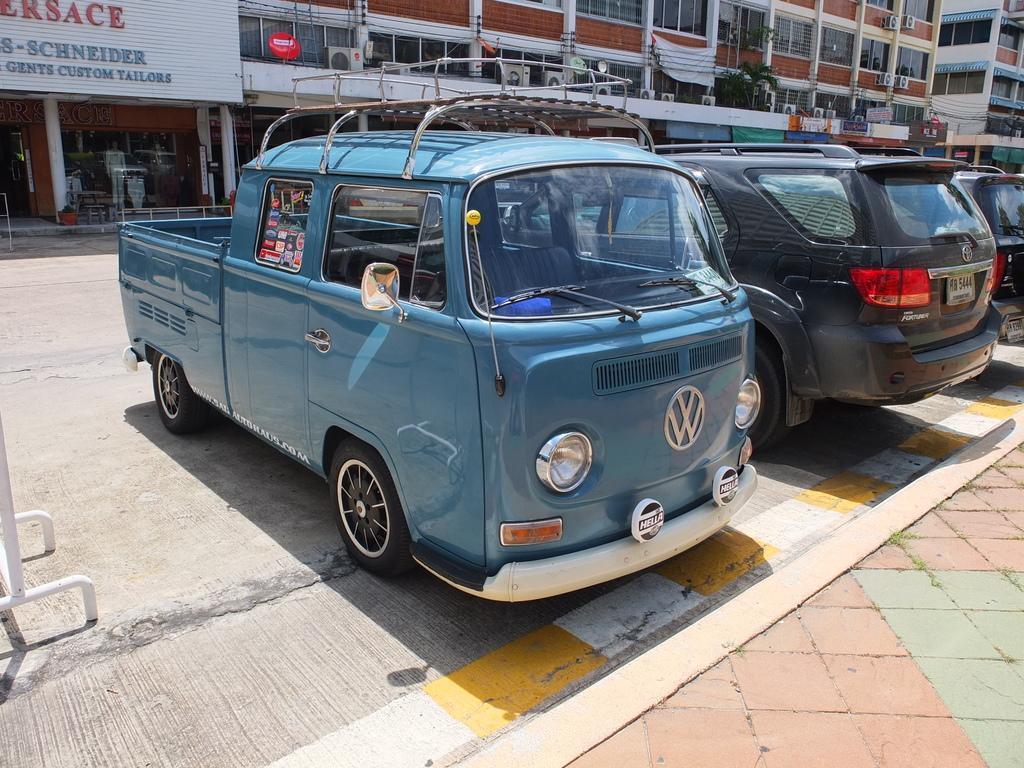In one or two sentences, can you explain what this image depicts? These are the cars, which are parked. I can see the buildings with the windows. This looks like a name board, which is attached to the building wall. 